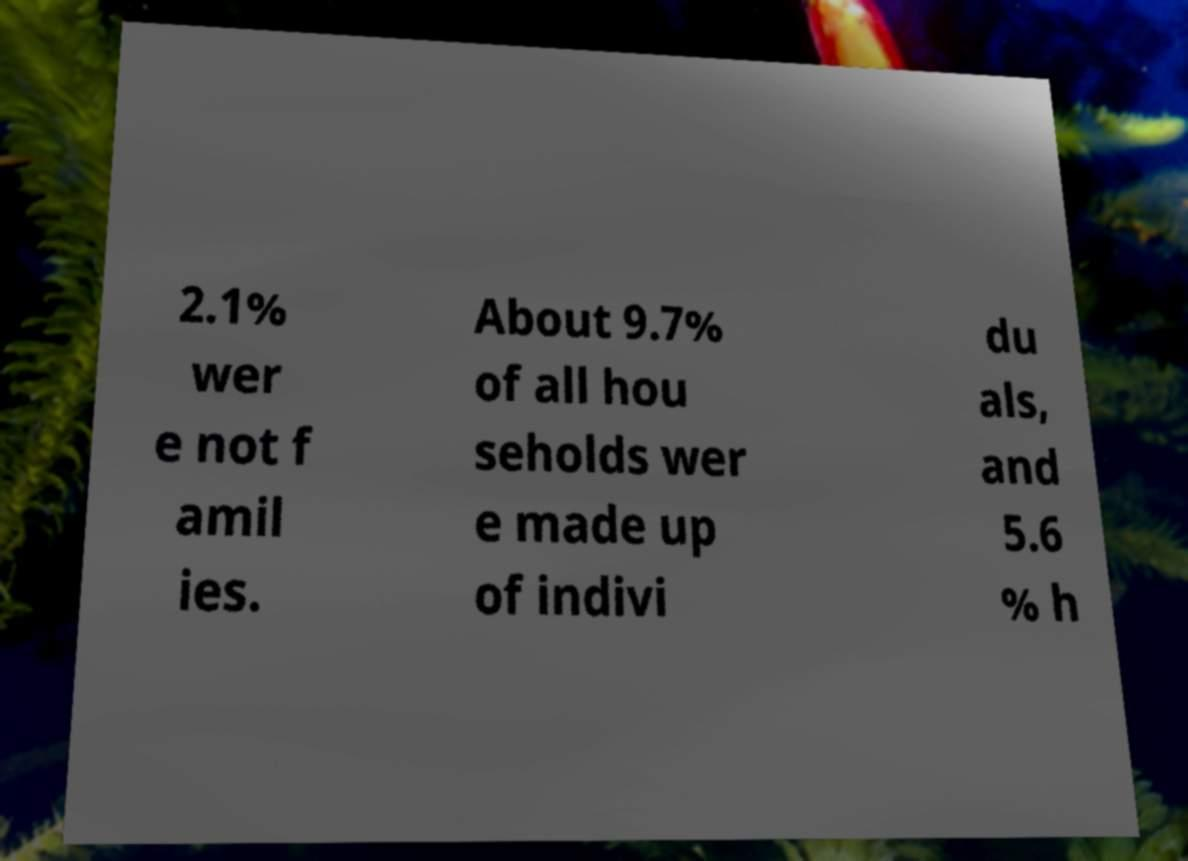What messages or text are displayed in this image? I need them in a readable, typed format. 2.1% wer e not f amil ies. About 9.7% of all hou seholds wer e made up of indivi du als, and 5.6 % h 